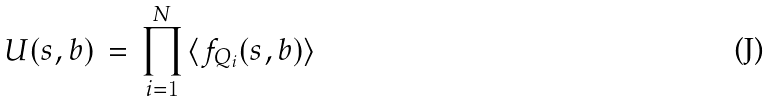<formula> <loc_0><loc_0><loc_500><loc_500>U ( s , b ) \, = \, \prod ^ { N } _ { i = 1 } \, \langle f _ { Q _ { i } } ( s , b ) \rangle</formula> 